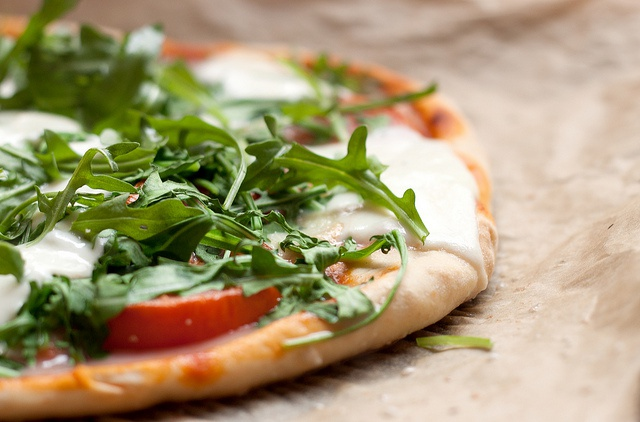Describe the objects in this image and their specific colors. I can see pizza in gray, darkgreen, ivory, olive, and black tones and dining table in gray, lightgray, and tan tones in this image. 